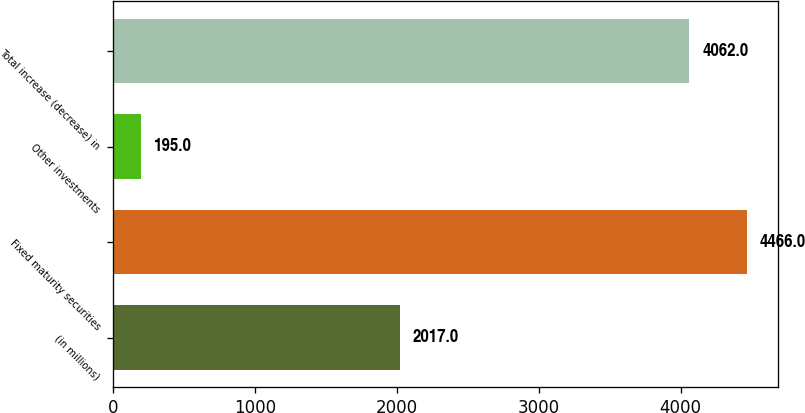Convert chart. <chart><loc_0><loc_0><loc_500><loc_500><bar_chart><fcel>(in millions)<fcel>Fixed maturity securities<fcel>Other investments<fcel>Total increase (decrease) in<nl><fcel>2017<fcel>4466<fcel>195<fcel>4062<nl></chart> 